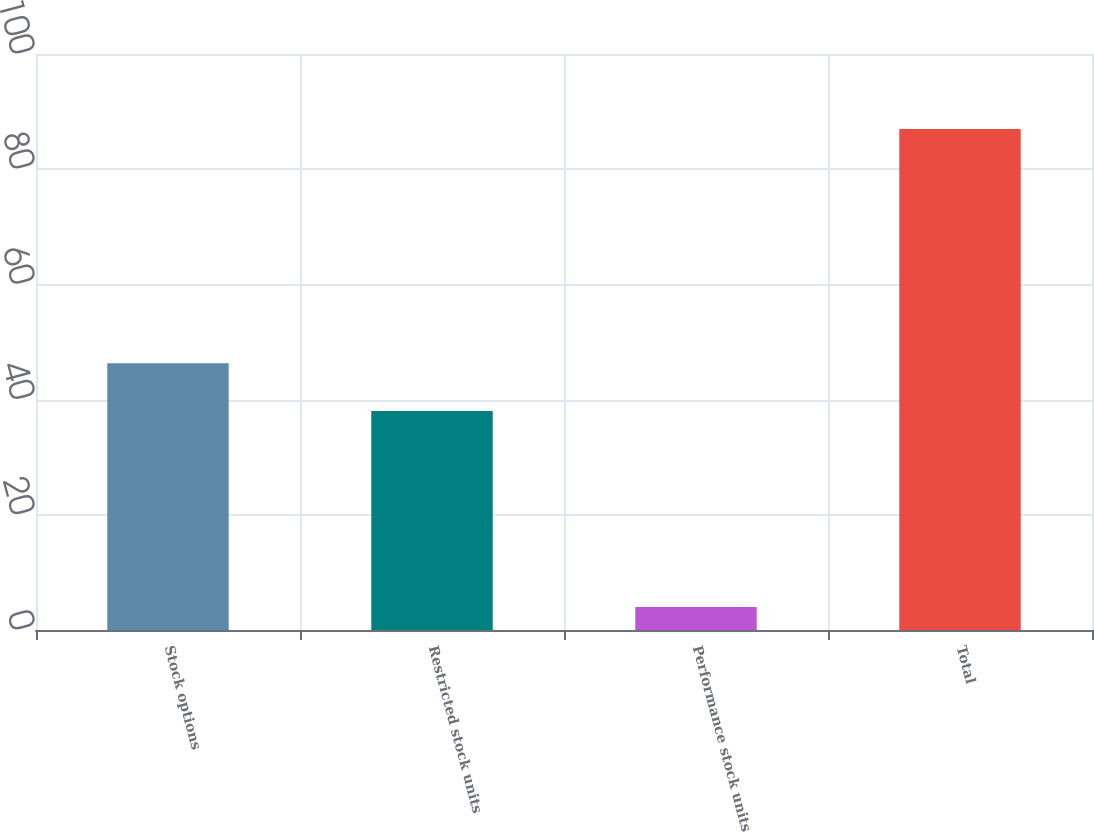<chart> <loc_0><loc_0><loc_500><loc_500><bar_chart><fcel>Stock options<fcel>Restricted stock units<fcel>Performance stock units<fcel>Total<nl><fcel>46.3<fcel>38<fcel>4<fcel>87<nl></chart> 